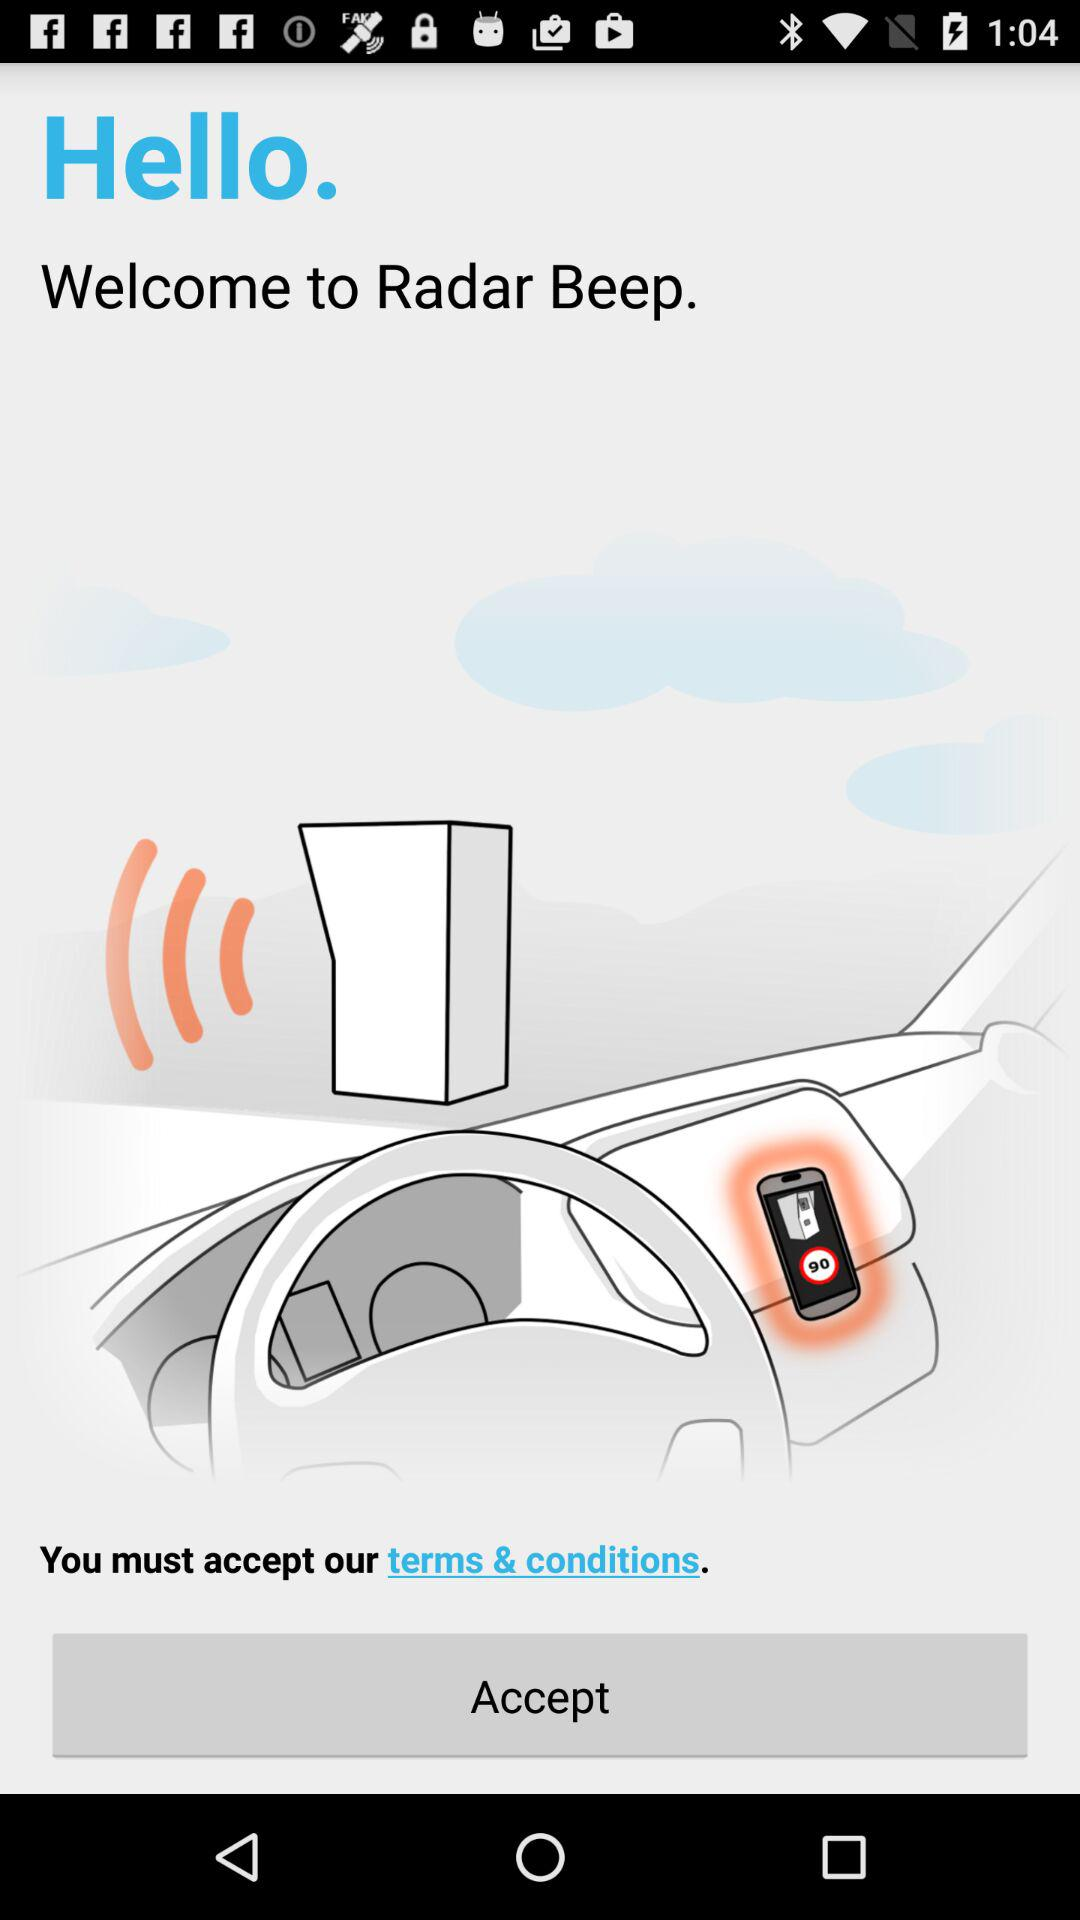What is the application name? The application name is "Radar Beep". 